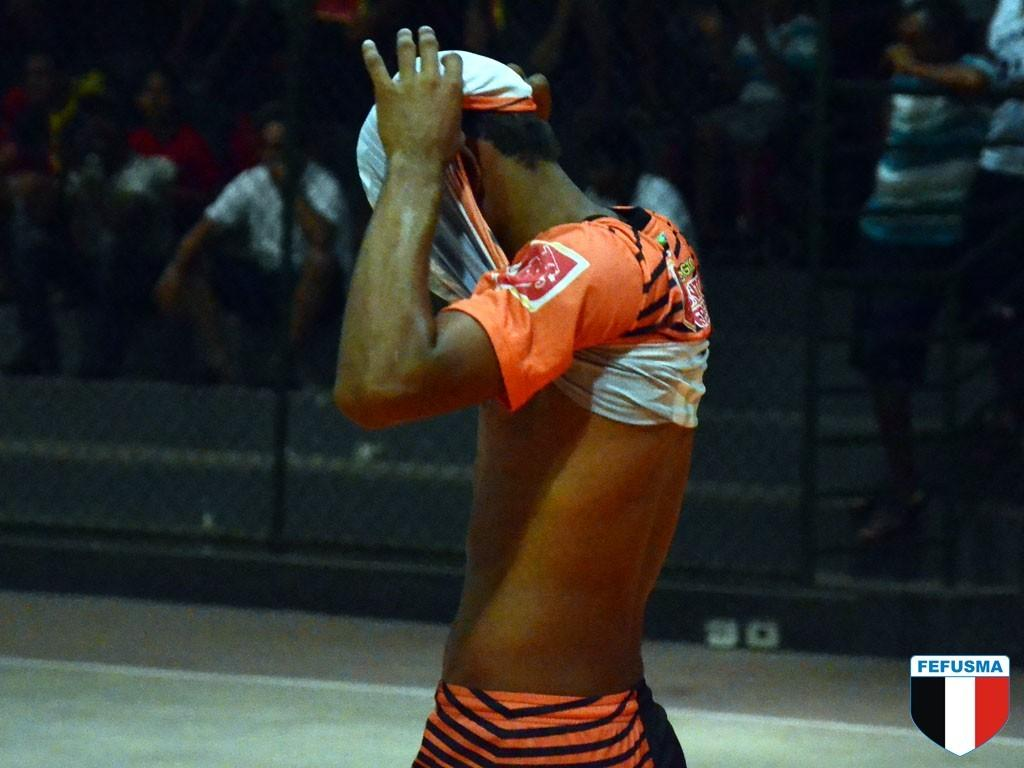<image>
Render a clear and concise summary of the photo. A man pulls his shirt over his head at a Fefusma game. 